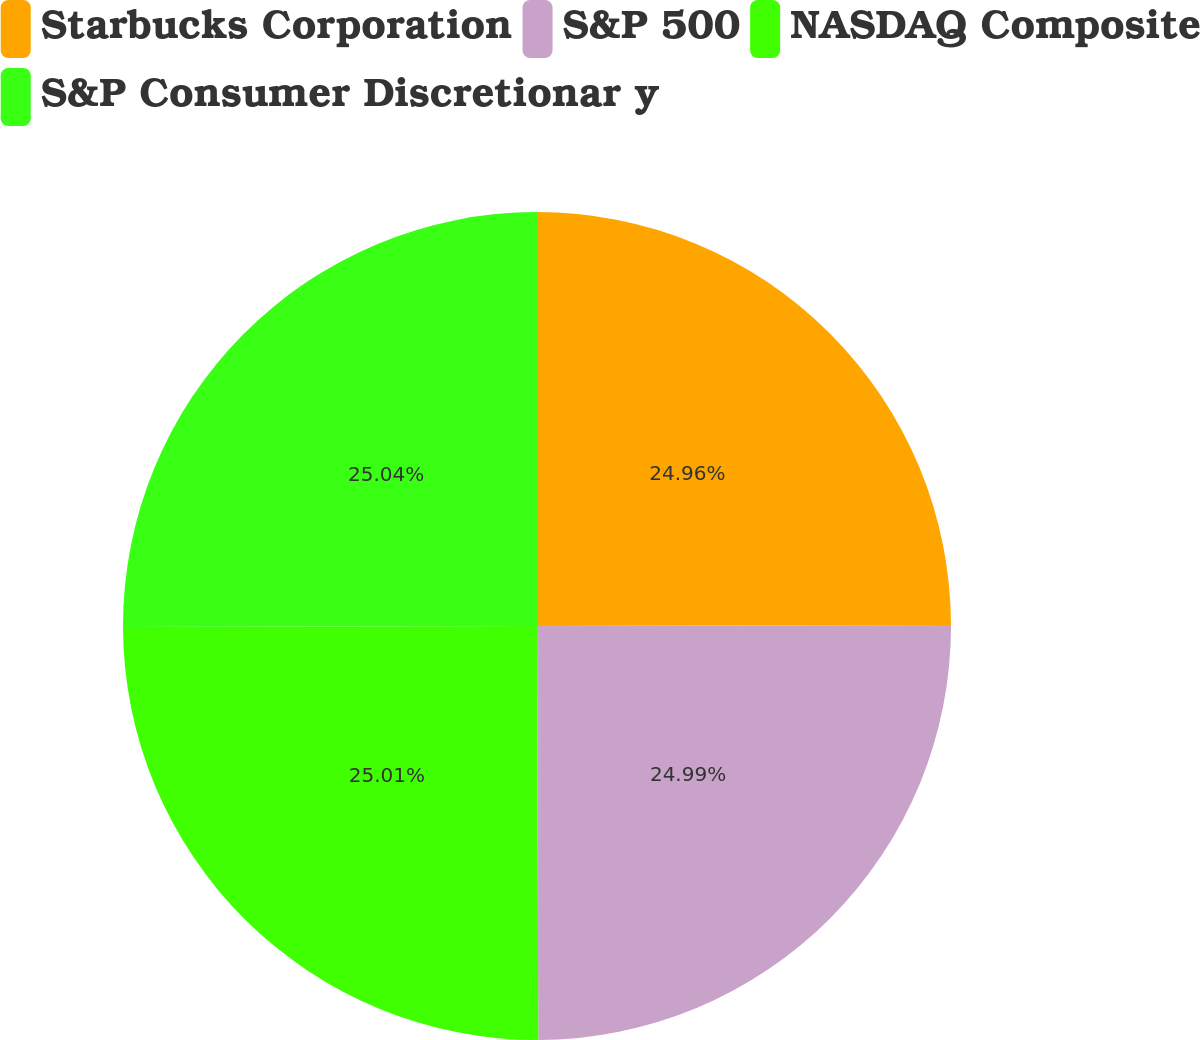Convert chart to OTSL. <chart><loc_0><loc_0><loc_500><loc_500><pie_chart><fcel>Starbucks Corporation<fcel>S&P 500<fcel>NASDAQ Composite<fcel>S&P Consumer Discretionar y<nl><fcel>24.96%<fcel>24.99%<fcel>25.01%<fcel>25.04%<nl></chart> 